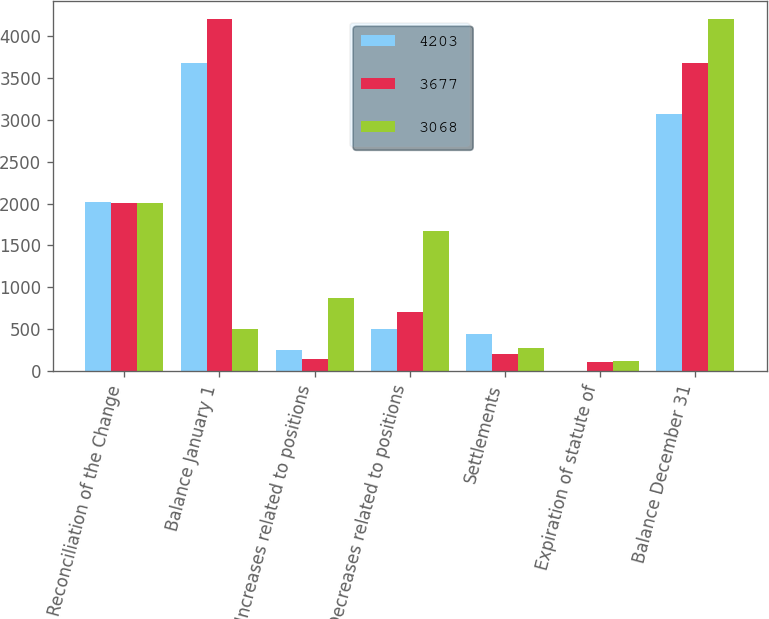<chart> <loc_0><loc_0><loc_500><loc_500><stacked_bar_chart><ecel><fcel>Reconciliation of the Change<fcel>Balance January 1<fcel>Increases related to positions<fcel>Decreases related to positions<fcel>Settlements<fcel>Expiration of statute of<fcel>Balance December 31<nl><fcel>4203<fcel>2013<fcel>3677<fcel>254<fcel>508<fcel>448<fcel>5<fcel>3068<nl><fcel>3677<fcel>2012<fcel>4203<fcel>142<fcel>711<fcel>205<fcel>104<fcel>3677<nl><fcel>3068<fcel>2011<fcel>508<fcel>879<fcel>1669<fcel>277<fcel>118<fcel>4203<nl></chart> 